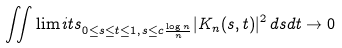Convert formula to latex. <formula><loc_0><loc_0><loc_500><loc_500>\iint \lim i t s _ { 0 \leq s \leq t \leq 1 , \, s \leq c \frac { \log n } { n } } | K _ { n } ( s , t ) | ^ { 2 } \, d s d t \rightarrow 0</formula> 